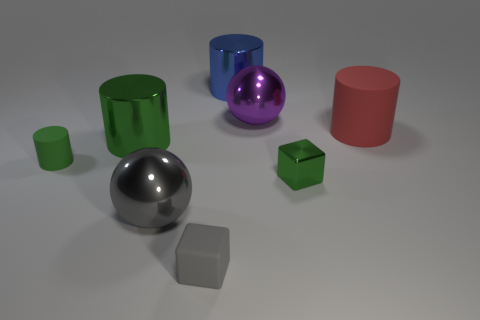There is a rubber object that is both behind the gray rubber block and on the left side of the red cylinder; what is its shape?
Ensure brevity in your answer.  Cylinder. What shape is the tiny object on the left side of the large object that is in front of the tiny green object that is right of the tiny rubber cylinder?
Provide a short and direct response. Cylinder. What is the thing that is to the left of the purple shiny thing and behind the red thing made of?
Provide a short and direct response. Metal. What number of metal cylinders have the same size as the green matte object?
Your answer should be compact. 0. How many rubber things are either spheres or large red cylinders?
Your answer should be very brief. 1. What is the material of the tiny gray thing?
Offer a very short reply. Rubber. There is a big purple ball; how many large things are to the left of it?
Offer a terse response. 3. Are the gray thing that is left of the gray matte thing and the blue cylinder made of the same material?
Keep it short and to the point. Yes. How many tiny matte objects have the same shape as the big green metallic object?
Your response must be concise. 1. How many large objects are either cyan balls or blue cylinders?
Your answer should be compact. 1. 